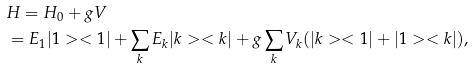<formula> <loc_0><loc_0><loc_500><loc_500>& H = H _ { 0 } + g V \\ & = E _ { 1 } | 1 > < 1 | + \sum _ { k } E _ { k } | k > < k | + g \sum _ { k } V _ { k } ( | k > < 1 | + | 1 > < k | ) ,</formula> 